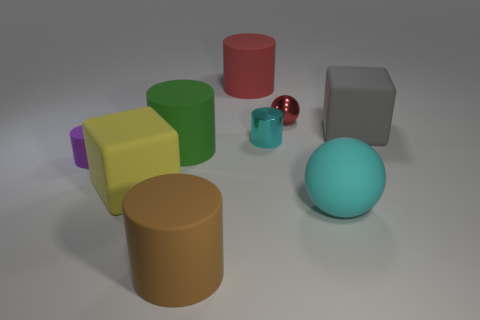What can you infer about the texture of these objects? From their appearance, the objects seem to have different textures. The large brown and small blue cylinders display a matte texture, indicative of a non-reflective surface such as rubber or plastic. The green cube, the yellow cuboid, and the gray cube also have matte finishes. The small purple cube has a slight sheen, suggesting a smoother surface, possibly coated with a different material or paint. The red sphere stands out with its reflective surface, suggesting it could be made of glass or polished metal. 